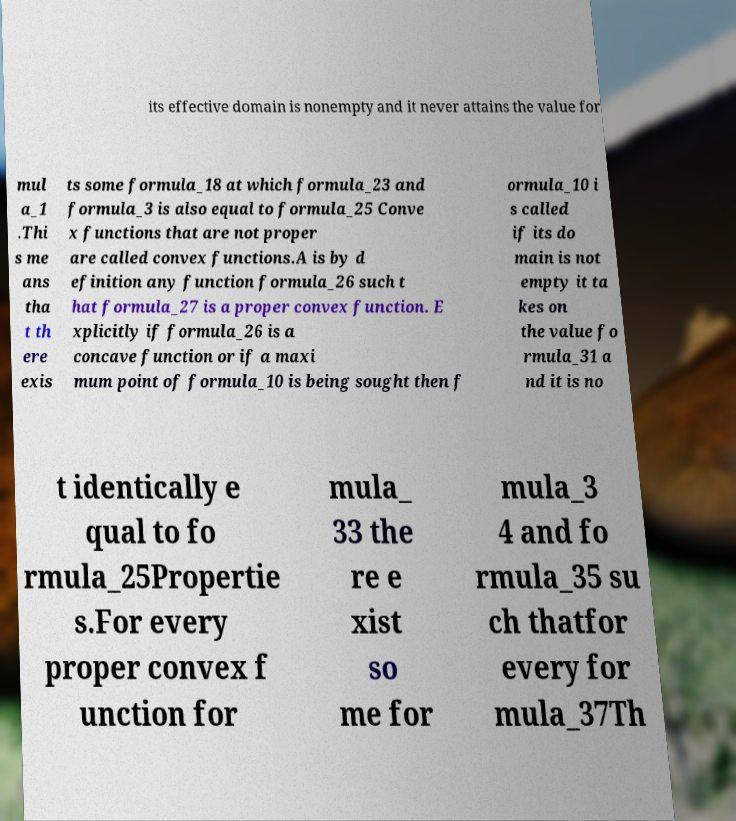Can you accurately transcribe the text from the provided image for me? its effective domain is nonempty and it never attains the value for mul a_1 .Thi s me ans tha t th ere exis ts some formula_18 at which formula_23 and formula_3 is also equal to formula_25 Conve x functions that are not proper are called convex functions.A is by d efinition any function formula_26 such t hat formula_27 is a proper convex function. E xplicitly if formula_26 is a concave function or if a maxi mum point of formula_10 is being sought then f ormula_10 i s called if its do main is not empty it ta kes on the value fo rmula_31 a nd it is no t identically e qual to fo rmula_25Propertie s.For every proper convex f unction for mula_ 33 the re e xist so me for mula_3 4 and fo rmula_35 su ch thatfor every for mula_37Th 